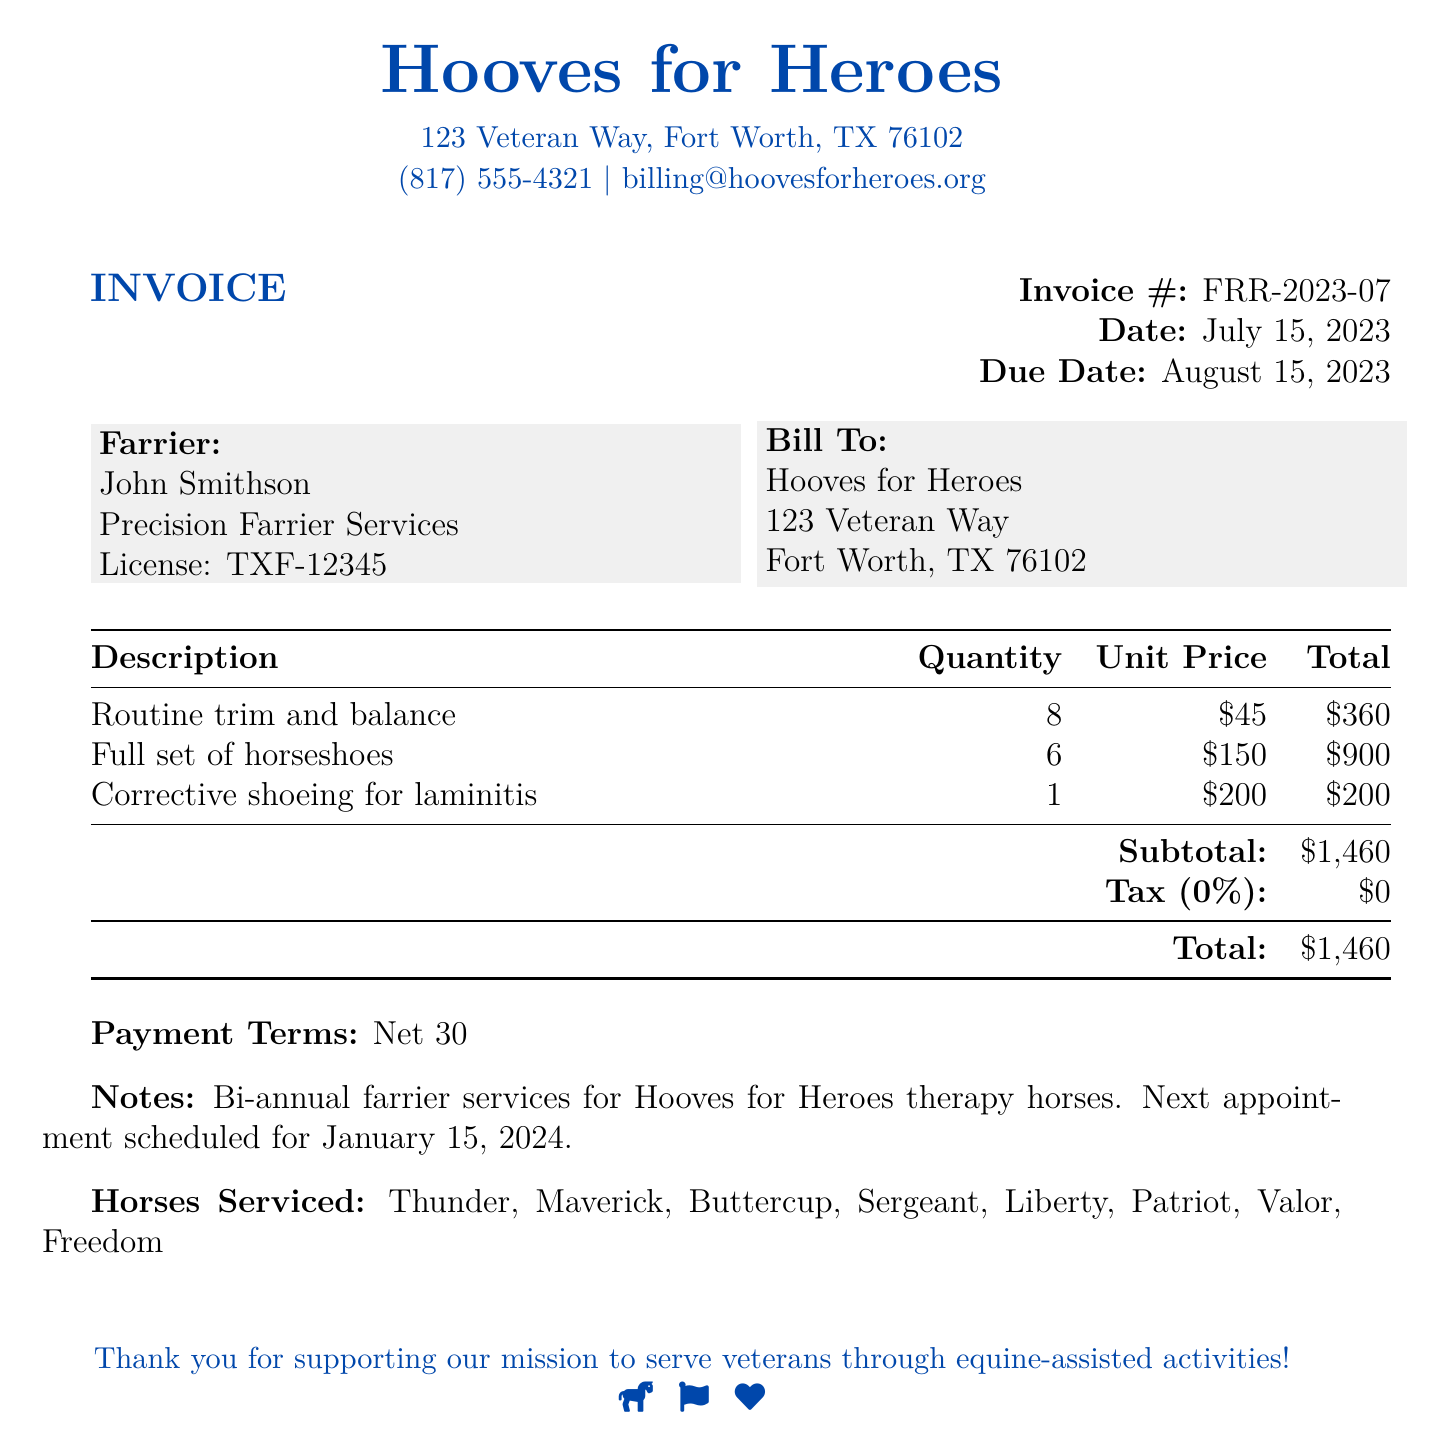what is the invoice number? The invoice number is specified in the document as FRR-2023-07.
Answer: FRR-2023-07 what is the total amount due? The total amount due is the final sum listed in the document, which is $1,460.
Answer: $1,460 who provided the farrier services? The farrier services were provided by John Smithson from Precision Farrier Services.
Answer: John Smithson when is the next appointment scheduled? The next appointment date is mentioned in the notes section of the invoice as January 15, 2024.
Answer: January 15, 2024 how many therapy horses were serviced? The document lists eight therapy horses serviced, which are Thunder, Maverick, Buttercup, Sergeant, Liberty, Patriot, Valor, and Freedom.
Answer: Eight what is the subtotal amount before tax? The subtotal amount before tax is clearly listed in the document as $1,460.
Answer: $1,460 what type of shoeing was provided for laminitis? The document specifies that corrective shoeing for laminitis was provided.
Answer: Corrective shoeing what are the payment terms? The payment terms are outlined as Net 30 in the document.
Answer: Net 30 what is the unit price for a full set of horseshoes? The unit price for a full set of horseshoes is provided as $150 in the document.
Answer: $150 who is billed for the services? The bill is addressed to Hooves for Heroes according to the document.
Answer: Hooves for Heroes 